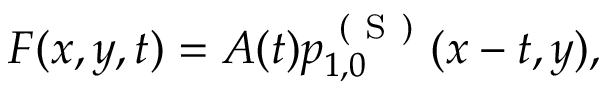Convert formula to latex. <formula><loc_0><loc_0><loc_500><loc_500>\begin{array} { r } { F ( x , y , t ) = A ( t ) p _ { 1 , 0 } ^ { ( S ) } ( x - t , y ) , } \end{array}</formula> 